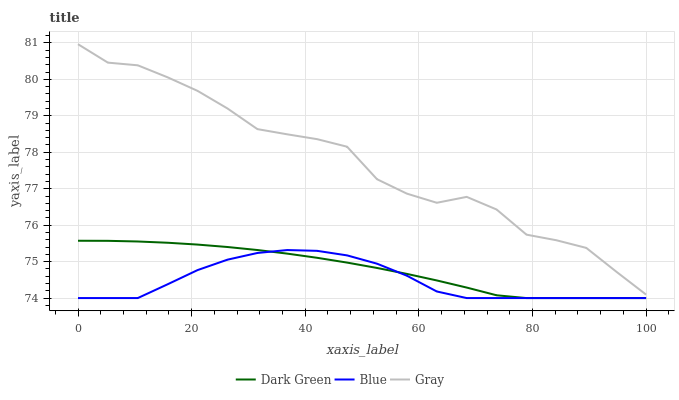Does Blue have the minimum area under the curve?
Answer yes or no. Yes. Does Gray have the maximum area under the curve?
Answer yes or no. Yes. Does Dark Green have the minimum area under the curve?
Answer yes or no. No. Does Dark Green have the maximum area under the curve?
Answer yes or no. No. Is Dark Green the smoothest?
Answer yes or no. Yes. Is Gray the roughest?
Answer yes or no. Yes. Is Gray the smoothest?
Answer yes or no. No. Is Dark Green the roughest?
Answer yes or no. No. Does Blue have the lowest value?
Answer yes or no. Yes. Does Gray have the lowest value?
Answer yes or no. No. Does Gray have the highest value?
Answer yes or no. Yes. Does Dark Green have the highest value?
Answer yes or no. No. Is Blue less than Gray?
Answer yes or no. Yes. Is Gray greater than Blue?
Answer yes or no. Yes. Does Dark Green intersect Blue?
Answer yes or no. Yes. Is Dark Green less than Blue?
Answer yes or no. No. Is Dark Green greater than Blue?
Answer yes or no. No. Does Blue intersect Gray?
Answer yes or no. No. 